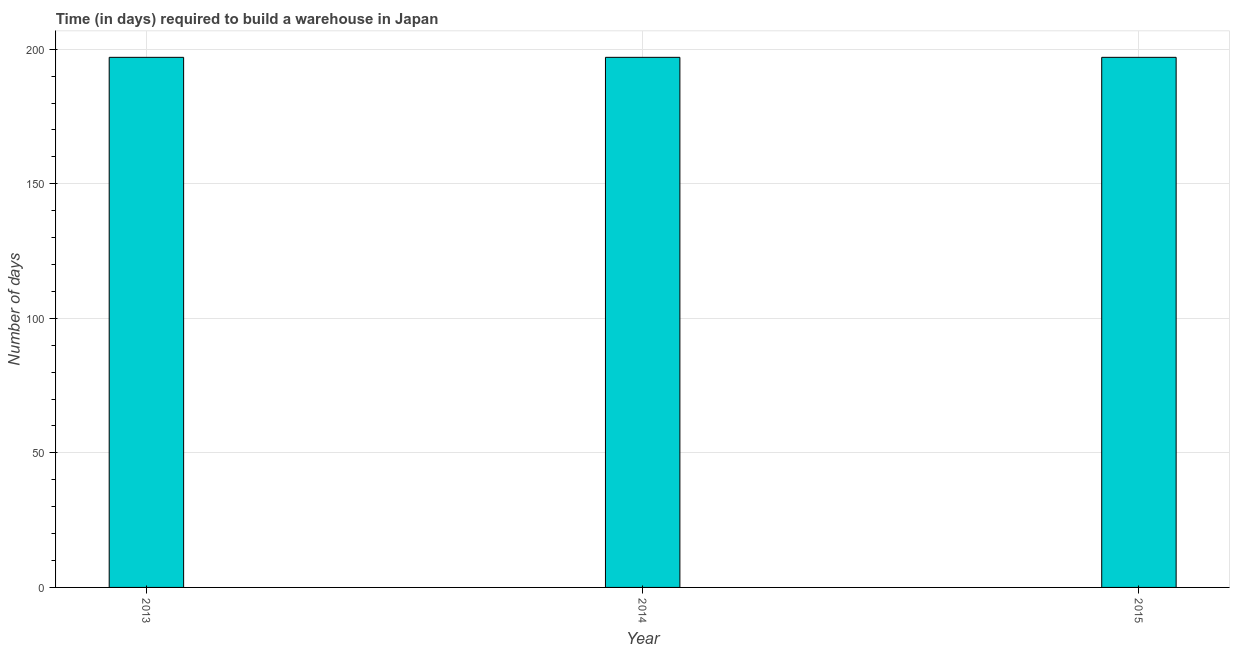What is the title of the graph?
Your answer should be very brief. Time (in days) required to build a warehouse in Japan. What is the label or title of the X-axis?
Your answer should be very brief. Year. What is the label or title of the Y-axis?
Give a very brief answer. Number of days. What is the time required to build a warehouse in 2015?
Your response must be concise. 197. Across all years, what is the maximum time required to build a warehouse?
Make the answer very short. 197. Across all years, what is the minimum time required to build a warehouse?
Offer a very short reply. 197. What is the sum of the time required to build a warehouse?
Give a very brief answer. 591. What is the difference between the time required to build a warehouse in 2013 and 2015?
Your answer should be very brief. 0. What is the average time required to build a warehouse per year?
Your answer should be compact. 197. What is the median time required to build a warehouse?
Provide a short and direct response. 197. Do a majority of the years between 2015 and 2013 (inclusive) have time required to build a warehouse greater than 120 days?
Give a very brief answer. Yes. What is the ratio of the time required to build a warehouse in 2013 to that in 2014?
Make the answer very short. 1. Is the difference between the time required to build a warehouse in 2014 and 2015 greater than the difference between any two years?
Give a very brief answer. Yes. What is the difference between the highest and the second highest time required to build a warehouse?
Your answer should be very brief. 0. Are all the bars in the graph horizontal?
Offer a terse response. No. How many years are there in the graph?
Provide a succinct answer. 3. What is the difference between two consecutive major ticks on the Y-axis?
Make the answer very short. 50. What is the Number of days in 2013?
Provide a short and direct response. 197. What is the Number of days in 2014?
Ensure brevity in your answer.  197. What is the Number of days of 2015?
Provide a succinct answer. 197. What is the difference between the Number of days in 2013 and 2014?
Make the answer very short. 0. What is the difference between the Number of days in 2013 and 2015?
Provide a short and direct response. 0. What is the difference between the Number of days in 2014 and 2015?
Keep it short and to the point. 0. What is the ratio of the Number of days in 2013 to that in 2014?
Your response must be concise. 1. What is the ratio of the Number of days in 2013 to that in 2015?
Provide a short and direct response. 1. What is the ratio of the Number of days in 2014 to that in 2015?
Give a very brief answer. 1. 